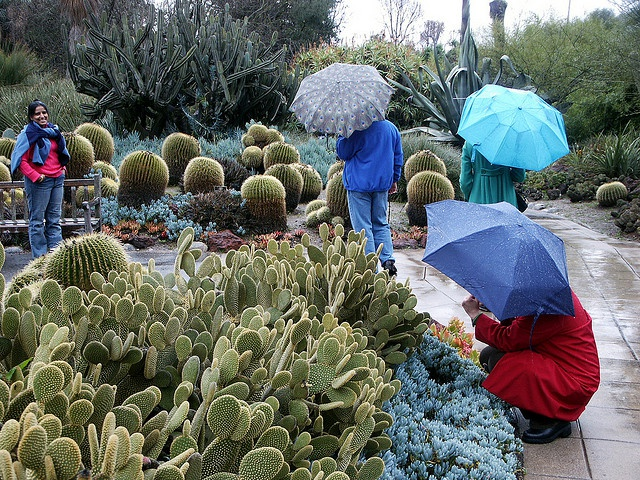Describe the objects in this image and their specific colors. I can see potted plant in teal, black, darkgreen, gray, and olive tones, umbrella in teal, blue, lightblue, and navy tones, people in teal, maroon, black, brown, and gray tones, umbrella in teal and lightblue tones, and people in teal, blue, navy, and darkblue tones in this image. 